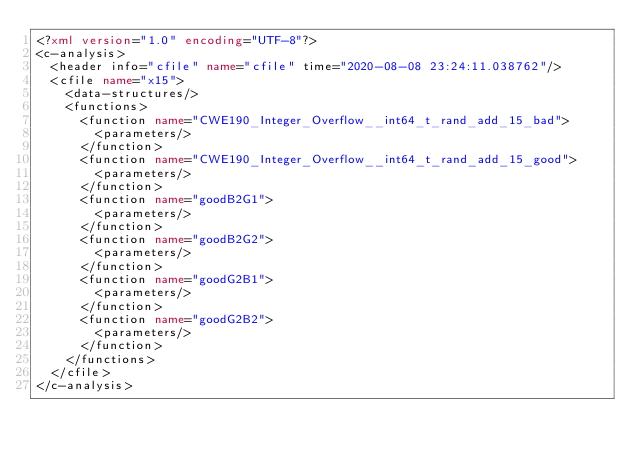Convert code to text. <code><loc_0><loc_0><loc_500><loc_500><_XML_><?xml version="1.0" encoding="UTF-8"?>
<c-analysis>
  <header info="cfile" name="cfile" time="2020-08-08 23:24:11.038762"/>
  <cfile name="x15">
    <data-structures/>
    <functions>
      <function name="CWE190_Integer_Overflow__int64_t_rand_add_15_bad">
        <parameters/>
      </function>
      <function name="CWE190_Integer_Overflow__int64_t_rand_add_15_good">
        <parameters/>
      </function>
      <function name="goodB2G1">
        <parameters/>
      </function>
      <function name="goodB2G2">
        <parameters/>
      </function>
      <function name="goodG2B1">
        <parameters/>
      </function>
      <function name="goodG2B2">
        <parameters/>
      </function>
    </functions>
  </cfile>
</c-analysis>
</code> 